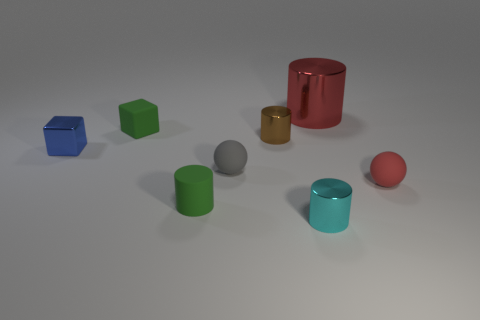Is the number of tiny red matte objects that are behind the big metal cylinder greater than the number of small gray matte spheres on the right side of the small brown cylinder?
Provide a succinct answer. No. Is there a brown object of the same shape as the tiny red matte thing?
Keep it short and to the point. No. There is a brown shiny thing that is the same size as the gray thing; what shape is it?
Ensure brevity in your answer.  Cylinder. There is a thing in front of the small green rubber cylinder; what is its shape?
Offer a terse response. Cylinder. Are there fewer green matte things in front of the blue thing than cylinders that are to the left of the big object?
Ensure brevity in your answer.  Yes. Do the cyan metal cylinder and the object on the right side of the large red shiny thing have the same size?
Provide a short and direct response. Yes. How many metallic cylinders have the same size as the rubber cylinder?
Your answer should be compact. 2. There is a large cylinder that is the same material as the tiny brown thing; what is its color?
Provide a succinct answer. Red. Are there more small green cylinders than tiny metallic things?
Ensure brevity in your answer.  No. Is the material of the cyan object the same as the red cylinder?
Your answer should be very brief. Yes. 